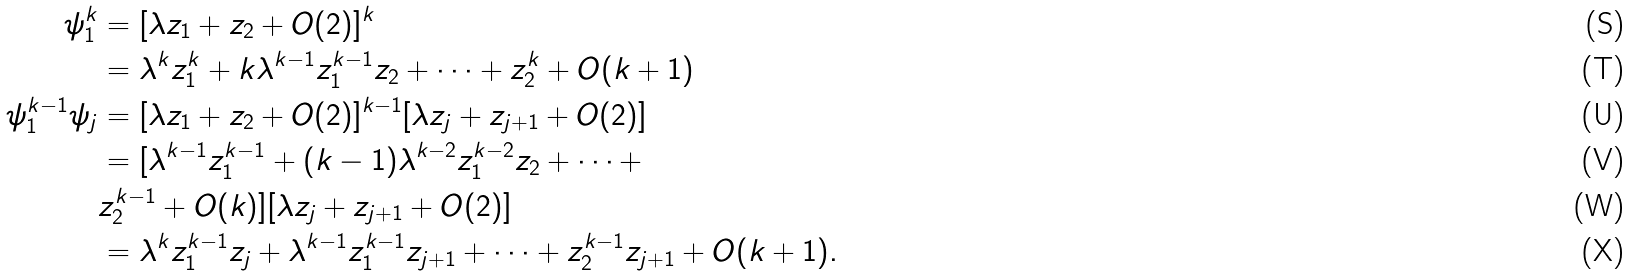Convert formula to latex. <formula><loc_0><loc_0><loc_500><loc_500>\psi _ { 1 } ^ { k } & = [ \lambda z _ { 1 } + z _ { 2 } + O ( 2 ) ] ^ { k } \\ & = \lambda ^ { k } z _ { 1 } ^ { k } + k \lambda ^ { k - 1 } z _ { 1 } ^ { k - 1 } z _ { 2 } + \dots + z _ { 2 } ^ { k } + O ( k + 1 ) \\ \psi _ { 1 } ^ { k - 1 } \psi _ { j } & = [ \lambda z _ { 1 } + z _ { 2 } + O ( 2 ) ] ^ { k - 1 } [ \lambda z _ { j } + z _ { j + 1 } + O ( 2 ) ] \\ & = [ \lambda ^ { k - 1 } z _ { 1 } ^ { k - 1 } + ( k - 1 ) \lambda ^ { k - 2 } z _ { 1 } ^ { k - 2 } z _ { 2 } + \dots + \\ & z _ { 2 } ^ { k - 1 } + O ( k ) ] [ \lambda z _ { j } + z _ { j + 1 } + O ( 2 ) ] \\ & = \lambda ^ { k } z _ { 1 } ^ { k - 1 } z _ { j } + \lambda ^ { k - 1 } z _ { 1 } ^ { k - 1 } z _ { j + 1 } + \dots + z _ { 2 } ^ { k - 1 } z _ { j + 1 } + O ( k + 1 ) .</formula> 